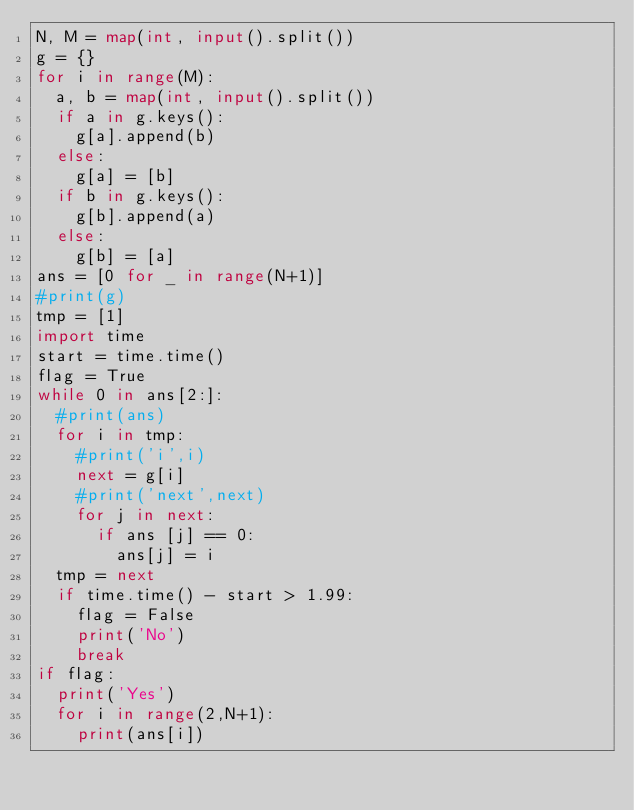Convert code to text. <code><loc_0><loc_0><loc_500><loc_500><_Python_>N, M = map(int, input().split())
g = {}
for i in range(M):
  a, b = map(int, input().split())
  if a in g.keys():
    g[a].append(b)
  else:
    g[a] = [b]
  if b in g.keys():
    g[b].append(a)
  else:
    g[b] = [a]
ans = [0 for _ in range(N+1)]
#print(g)
tmp = [1]
import time
start = time.time()
flag = True
while 0 in ans[2:]:
  #print(ans)
  for i in tmp:
    #print('i',i)
    next = g[i]
    #print('next',next)
    for j in next:
      if ans [j] == 0:
        ans[j] = i
  tmp = next
  if time.time() - start > 1.99:
    flag = False
    print('No')
    break
if flag:
  print('Yes')
  for i in range(2,N+1):
    print(ans[i])</code> 